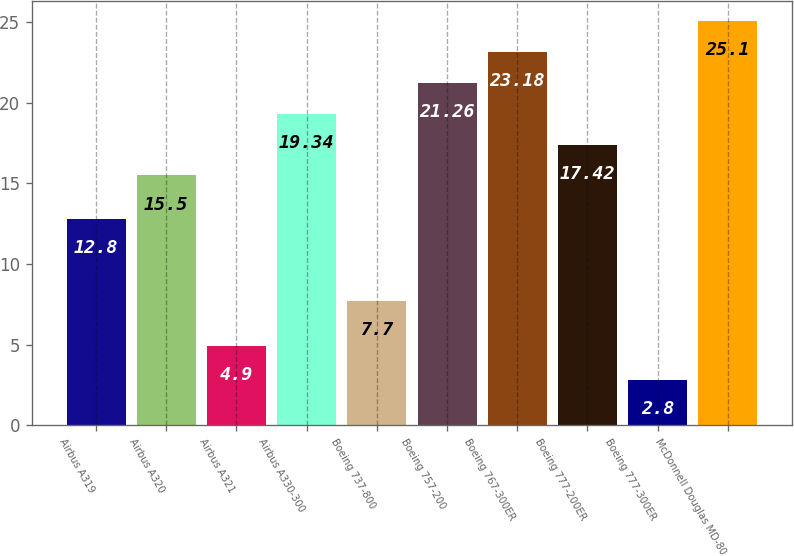Convert chart to OTSL. <chart><loc_0><loc_0><loc_500><loc_500><bar_chart><fcel>Airbus A319<fcel>Airbus A320<fcel>Airbus A321<fcel>Airbus A330-300<fcel>Boeing 737-800<fcel>Boeing 757-200<fcel>Boeing 767-300ER<fcel>Boeing 777-200ER<fcel>Boeing 777-300ER<fcel>McDonnell Douglas MD-80<nl><fcel>12.8<fcel>15.5<fcel>4.9<fcel>19.34<fcel>7.7<fcel>21.26<fcel>23.18<fcel>17.42<fcel>2.8<fcel>25.1<nl></chart> 